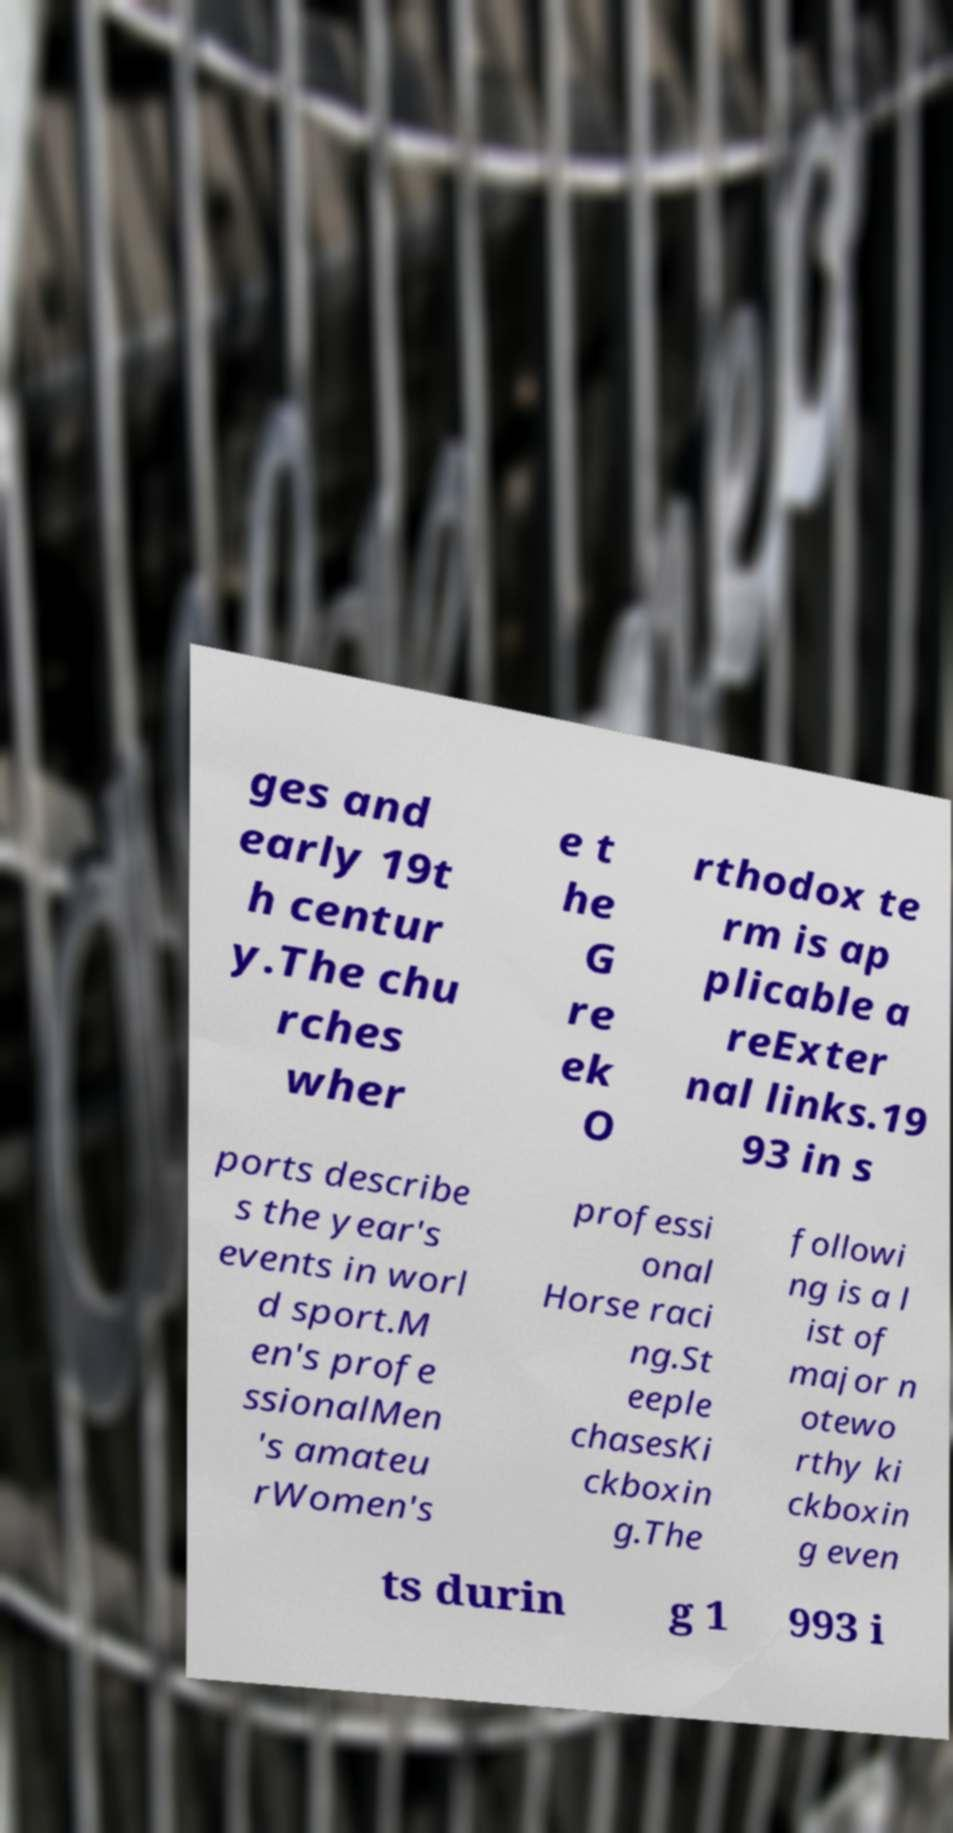Please read and relay the text visible in this image. What does it say? ges and early 19t h centur y.The chu rches wher e t he G re ek O rthodox te rm is ap plicable a reExter nal links.19 93 in s ports describe s the year's events in worl d sport.M en's profe ssionalMen 's amateu rWomen's professi onal Horse raci ng.St eeple chasesKi ckboxin g.The followi ng is a l ist of major n otewo rthy ki ckboxin g even ts durin g 1 993 i 